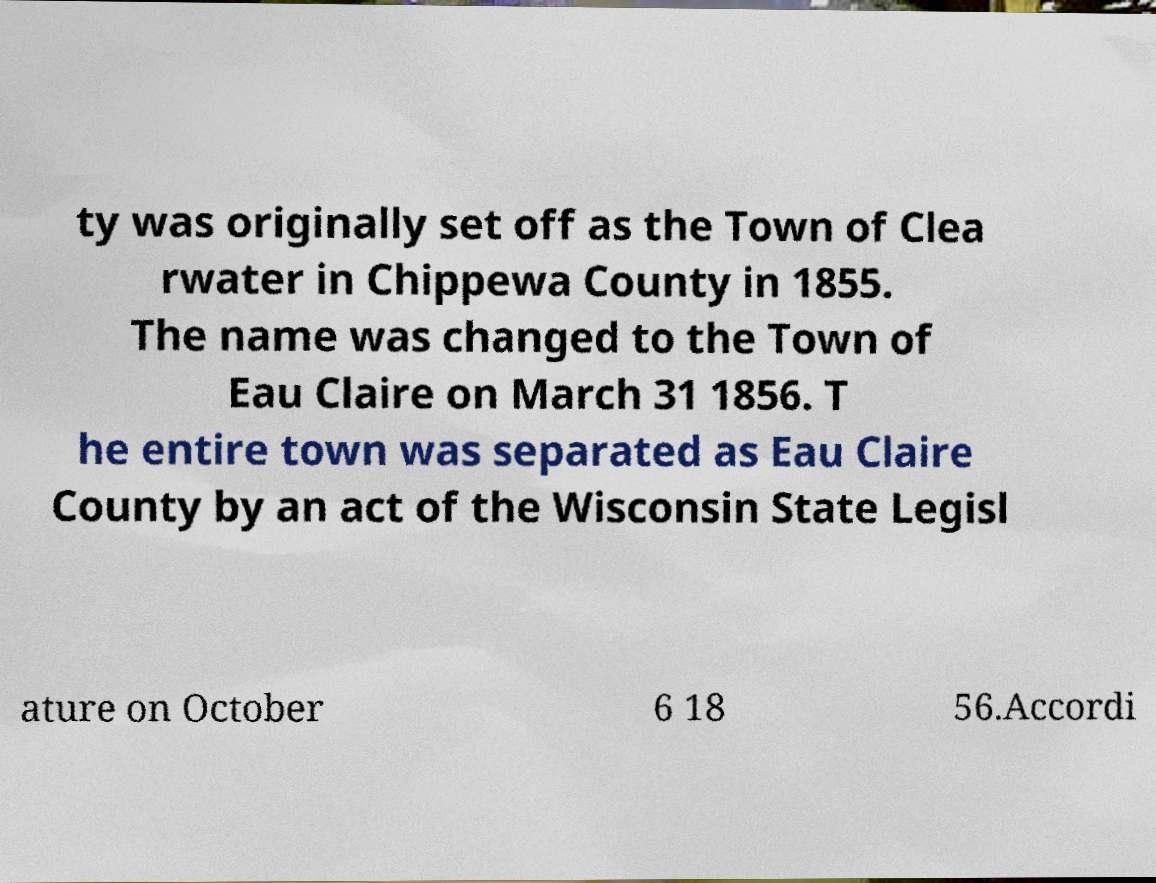There's text embedded in this image that I need extracted. Can you transcribe it verbatim? ty was originally set off as the Town of Clea rwater in Chippewa County in 1855. The name was changed to the Town of Eau Claire on March 31 1856. T he entire town was separated as Eau Claire County by an act of the Wisconsin State Legisl ature on October 6 18 56.Accordi 